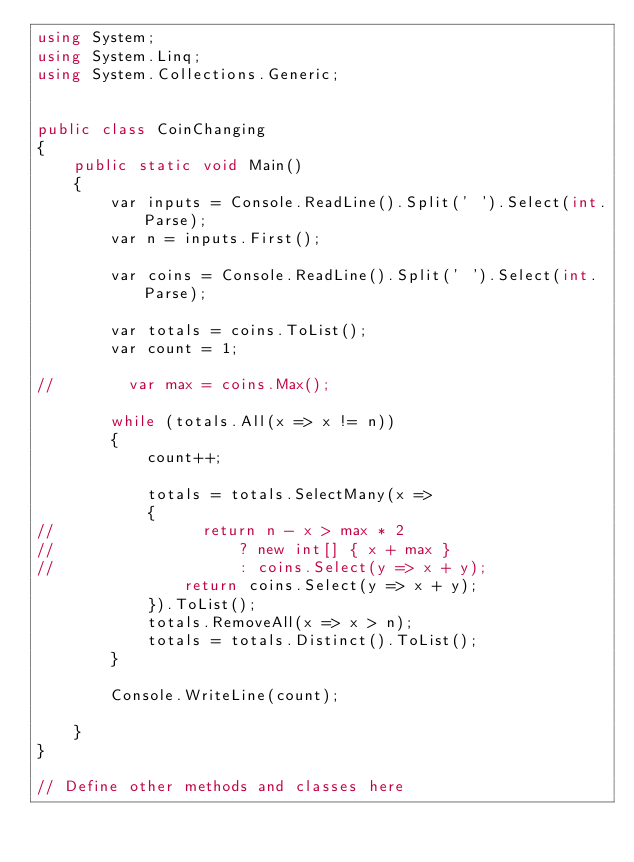Convert code to text. <code><loc_0><loc_0><loc_500><loc_500><_C#_>using System;
using System.Linq;
using System.Collections.Generic;


public class CoinChanging
{
    public static void Main()
    {
        var inputs = Console.ReadLine().Split(' ').Select(int.Parse);
        var n = inputs.First();
        
        var coins = Console.ReadLine().Split(' ').Select(int.Parse);
        
        var totals = coins.ToList();
        var count = 1;
        
//        var max = coins.Max();
        
        while (totals.All(x => x != n))
        {
            count++;
            
            totals = totals.SelectMany(x => 
            {
//                return n - x > max * 2
//                    ? new int[] { x + max }
//                    : coins.Select(y => x + y);
                return coins.Select(y => x + y);
            }).ToList();
            totals.RemoveAll(x => x > n);
            totals = totals.Distinct().ToList();
        }
    
        Console.WriteLine(count);
    
    }
}

// Define other methods and classes here</code> 